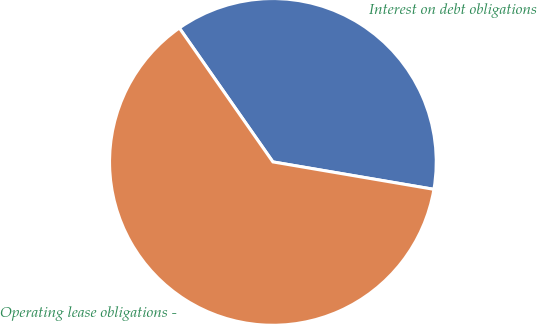<chart> <loc_0><loc_0><loc_500><loc_500><pie_chart><fcel>Interest on debt obligations<fcel>Operating lease obligations -<nl><fcel>37.39%<fcel>62.61%<nl></chart> 